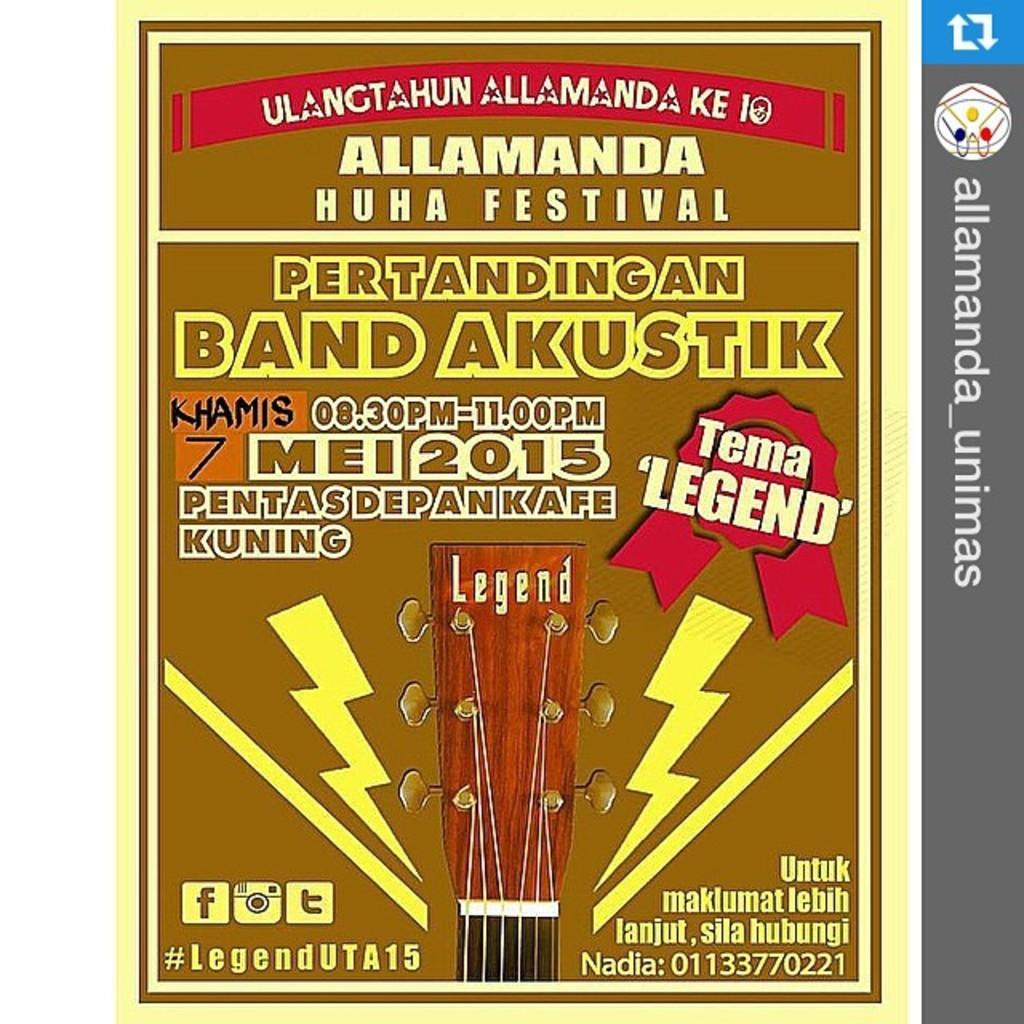How would you summarize this image in a sentence or two? In this image, we can see a poster, on that poster there is some text printed. 